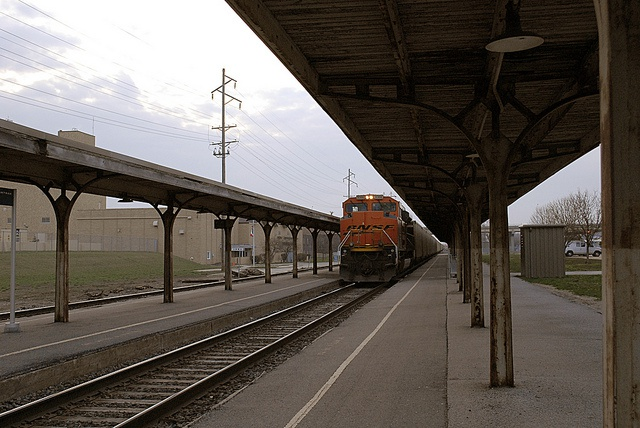Describe the objects in this image and their specific colors. I can see train in white, black, maroon, and gray tones and car in white, gray, and black tones in this image. 